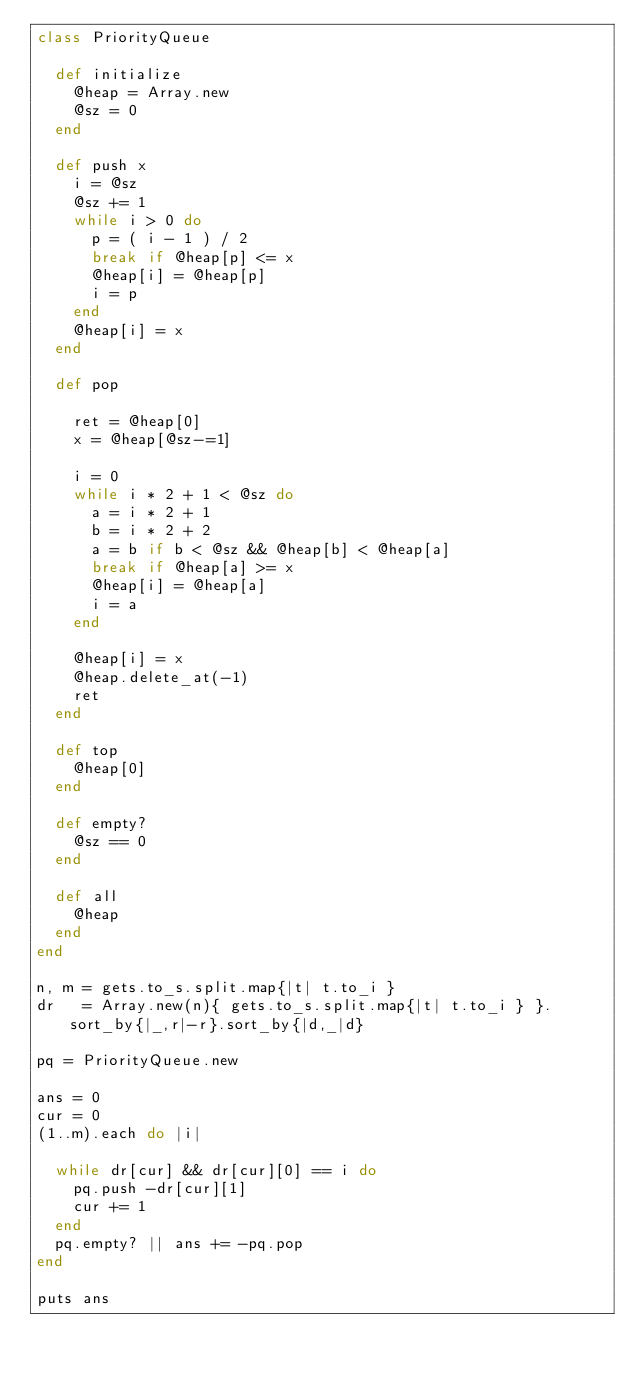<code> <loc_0><loc_0><loc_500><loc_500><_Ruby_>class PriorityQueue
  
  def initialize
    @heap = Array.new
    @sz = 0
  end
  
  def push x
    i = @sz
    @sz += 1
    while i > 0 do
      p = ( i - 1 ) / 2
      break if @heap[p] <= x
      @heap[i] = @heap[p]
      i = p
    end
    @heap[i] = x
  end
  
  def pop
    
    ret = @heap[0]
    x = @heap[@sz-=1]
    
    i = 0
    while i * 2 + 1 < @sz do
      a = i * 2 + 1
      b = i * 2 + 2
      a = b if b < @sz && @heap[b] < @heap[a]
      break if @heap[a] >= x
      @heap[i] = @heap[a]
      i = a
    end
    
    @heap[i] = x
    @heap.delete_at(-1)
    ret
  end
  
  def top
    @heap[0]
  end
  
  def empty?
    @sz == 0
  end
  
  def all
    @heap
  end
end

n, m = gets.to_s.split.map{|t| t.to_i }
dr   = Array.new(n){ gets.to_s.split.map{|t| t.to_i } }.sort_by{|_,r|-r}.sort_by{|d,_|d}

pq = PriorityQueue.new

ans = 0
cur = 0
(1..m).each do |i|
  
  while dr[cur] && dr[cur][0] == i do
    pq.push -dr[cur][1]
    cur += 1
  end
  pq.empty? || ans += -pq.pop
end

puts ans</code> 